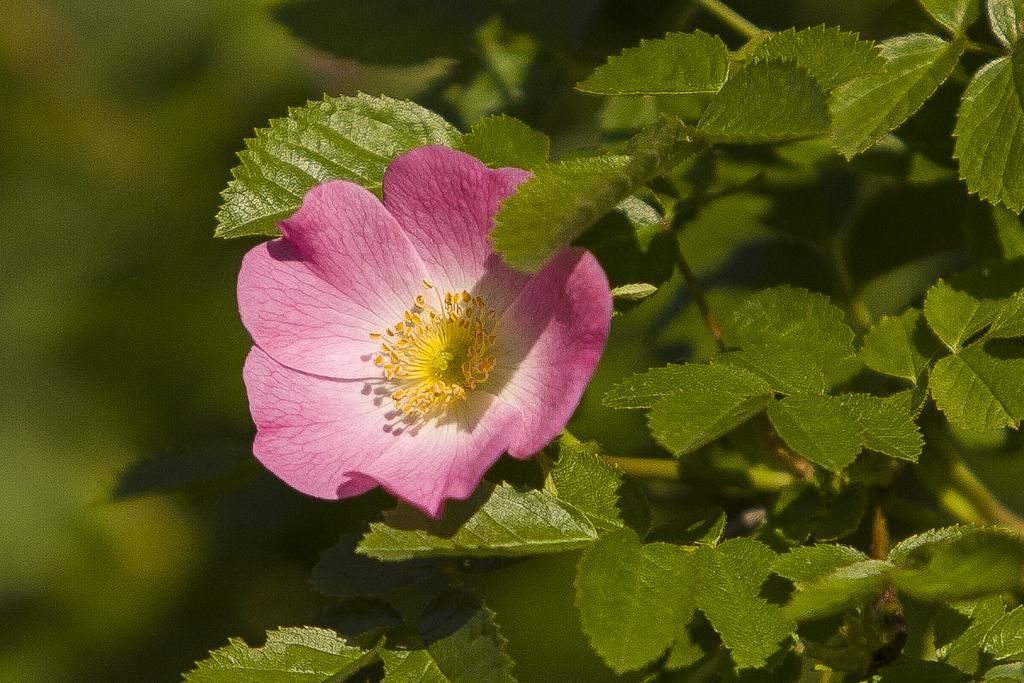What type of plant is featured in the image? There is a plant with a pink flower in the image. Are there any other plants visible in the image? There are other plants beside the plant with the pink flower, but they are not clearly visible. What type of celery is being used to water the plants in the image? There is no celery present in the image, and no indication that any plants are being watered. 